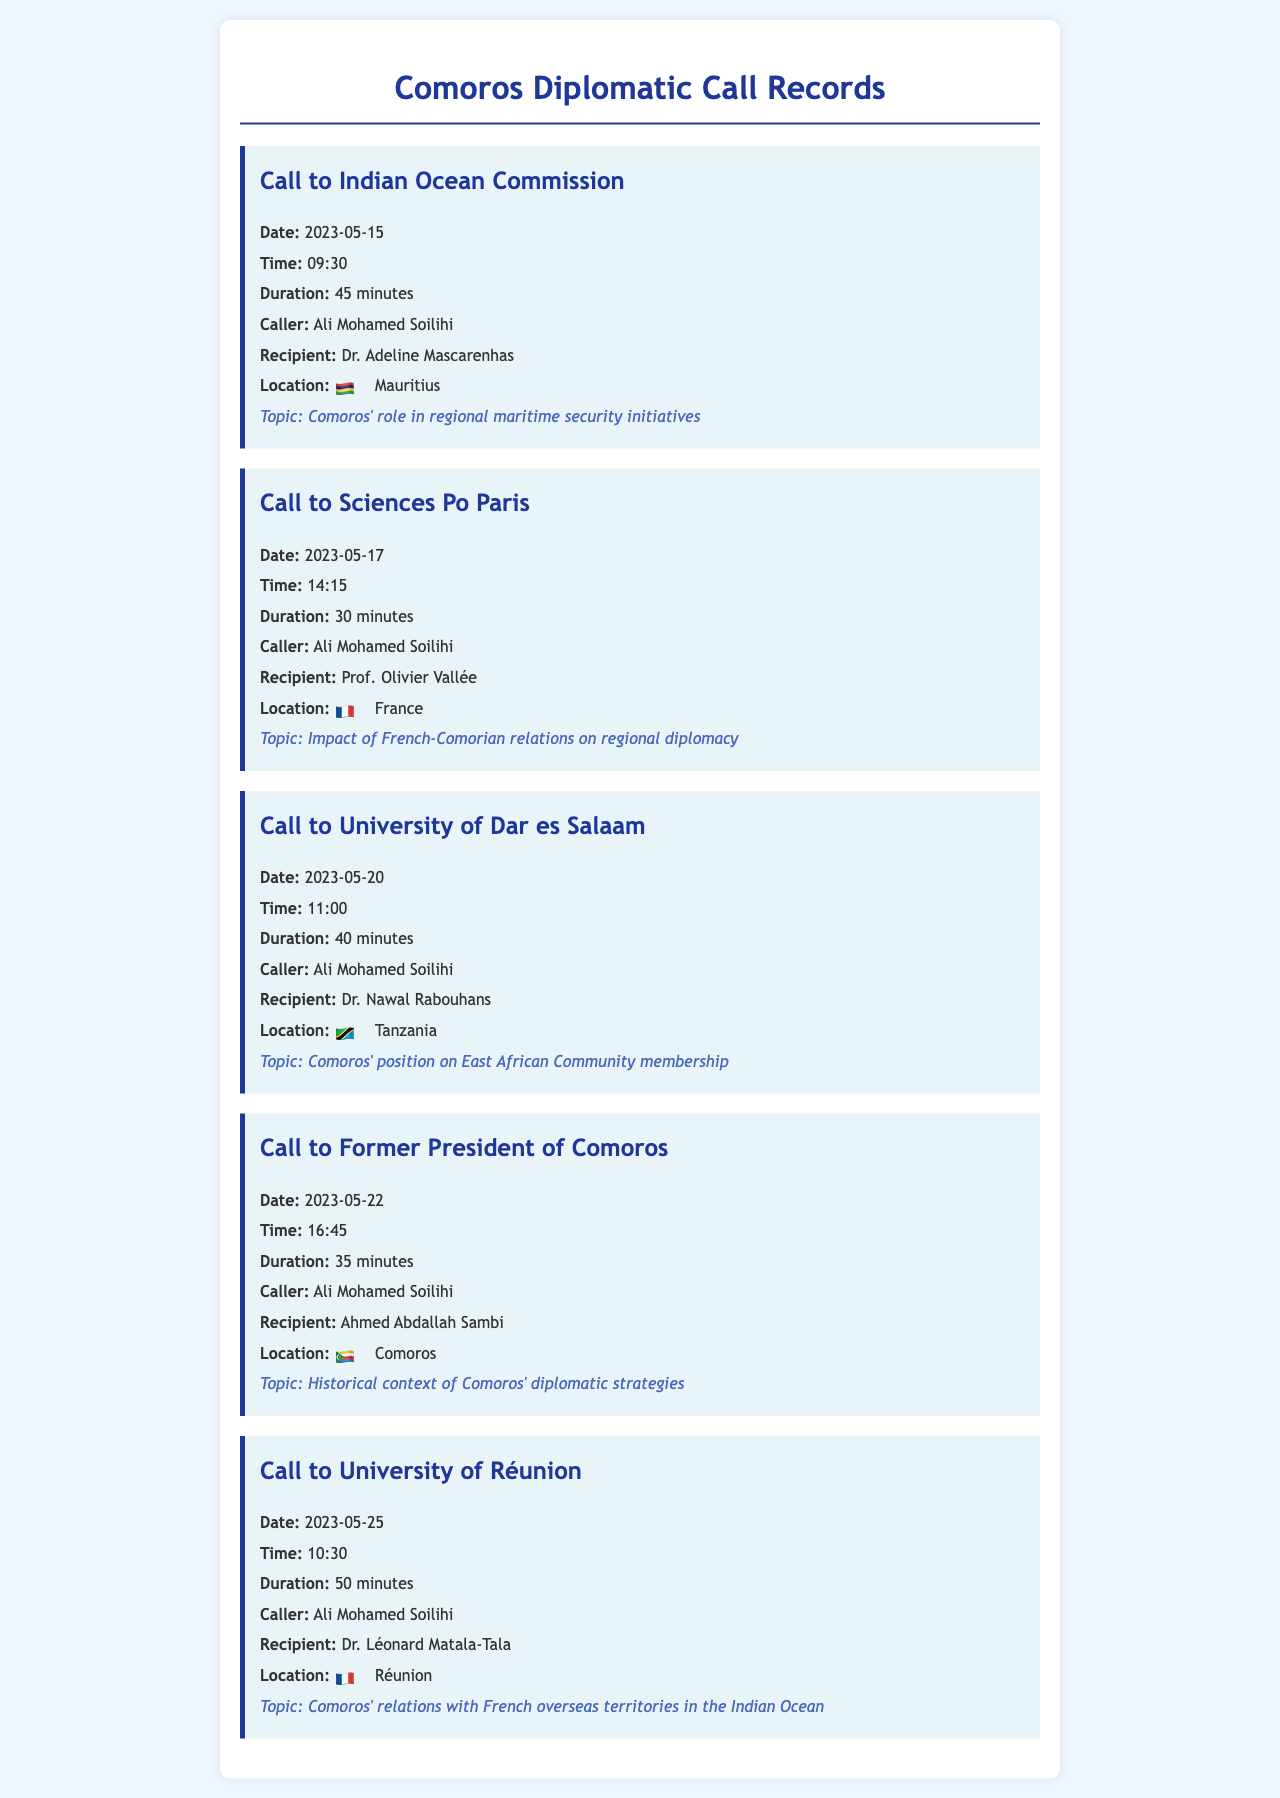What is the date of the call to the Indian Ocean Commission? The document states that the call to the Indian Ocean Commission took place on May 15, 2023.
Answer: May 15, 2023 Who was the recipient of the call to Sciences Po Paris? The recipient of the call to Sciences Po Paris was Prof. Olivier Vallée.
Answer: Prof. Olivier Vallée What was the duration of the call to University of Réunion? The call to University of Réunion lasted for 50 minutes.
Answer: 50 minutes What is the main topic discussed in the call to the Former President of Comoros? The main topic discussed was the historical context of Comoros' diplomatic strategies.
Answer: Historical context of Comoros' diplomatic strategies How many minutes long was the call to the University of Dar es Salaam? The duration of the call to the University of Dar es Salaam was 40 minutes.
Answer: 40 minutes What location was associated with the call to Dr. Nawal Rabouhans? The location of the call to Dr. Nawal Rabouhans was Tanzania.
Answer: Tanzania Which caller made the majority of the recorded calls? The majority of the recorded calls were made by Ali Mohamed Soilihi.
Answer: Ali Mohamed Soilihi What nationality is Dr. Adeline Mascarenhas? Dr. Adeline Mascarenhas is associated with Mauritius.
Answer: Mauritius Which political figure was involved in the call about Comoros' historical diplomatic strategies? The political figure involved was Ahmed Abdallah Sambi.
Answer: Ahmed Abdallah Sambi 